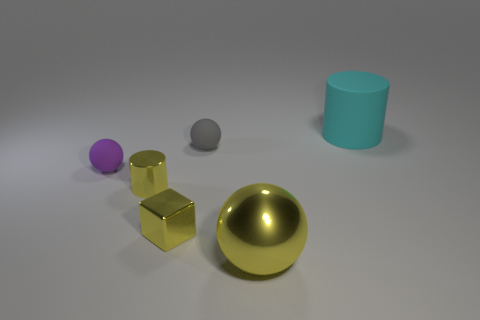Is there a large yellow shiny object that is behind the small matte sphere that is behind the small purple rubber object?
Give a very brief answer. No. There is a big thing that is behind the big yellow metal thing; is its color the same as the cylinder in front of the gray rubber sphere?
Ensure brevity in your answer.  No. There is a cube that is the same size as the yellow cylinder; what color is it?
Your answer should be compact. Yellow. Are there the same number of purple matte balls left of the gray matte ball and yellow shiny spheres that are behind the small yellow metal block?
Provide a succinct answer. No. There is a ball that is on the left side of the rubber ball to the right of the small purple matte sphere; what is its material?
Offer a terse response. Rubber. What number of objects are purple rubber spheres or large cyan cylinders?
Make the answer very short. 2. There is a cube that is the same color as the metal cylinder; what size is it?
Ensure brevity in your answer.  Small. Is the number of yellow metal things less than the number of big matte cylinders?
Provide a short and direct response. No. The other ball that is made of the same material as the tiny gray sphere is what size?
Your answer should be compact. Small. How big is the yellow cylinder?
Offer a very short reply. Small. 